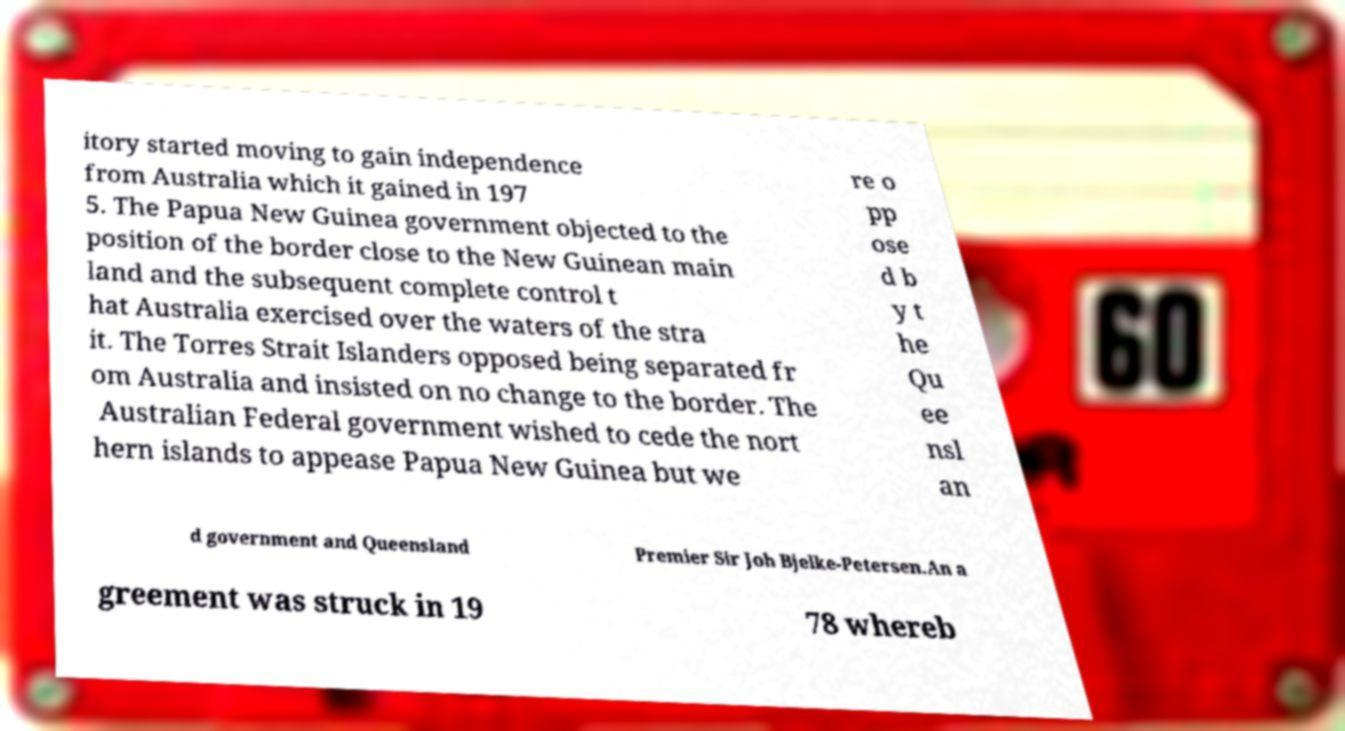Could you assist in decoding the text presented in this image and type it out clearly? itory started moving to gain independence from Australia which it gained in 197 5. The Papua New Guinea government objected to the position of the border close to the New Guinean main land and the subsequent complete control t hat Australia exercised over the waters of the stra it. The Torres Strait Islanders opposed being separated fr om Australia and insisted on no change to the border. The Australian Federal government wished to cede the nort hern islands to appease Papua New Guinea but we re o pp ose d b y t he Qu ee nsl an d government and Queensland Premier Sir Joh Bjelke-Petersen.An a greement was struck in 19 78 whereb 